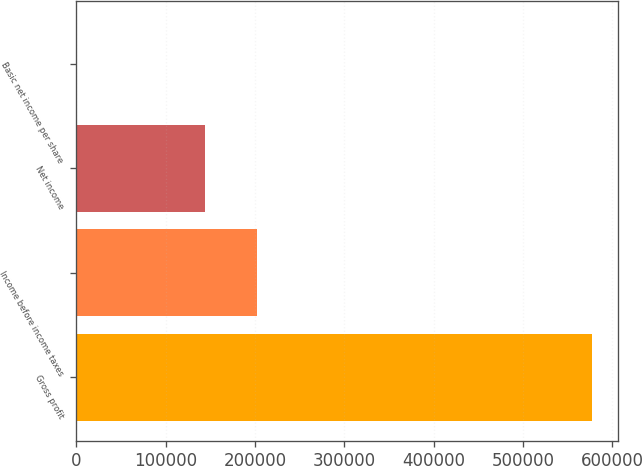Convert chart to OTSL. <chart><loc_0><loc_0><loc_500><loc_500><bar_chart><fcel>Gross profit<fcel>Income before income taxes<fcel>Net income<fcel>Basic net income per share<nl><fcel>577144<fcel>201565<fcel>143851<fcel>0.24<nl></chart> 